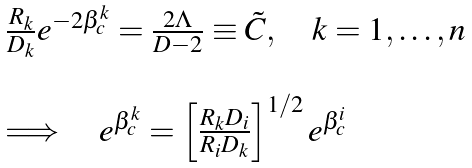Convert formula to latex. <formula><loc_0><loc_0><loc_500><loc_500>\begin{array} { l } \frac { R _ { k } } { D _ { k } } e ^ { - 2 \beta _ { c } ^ { k } } = \frac { 2 \Lambda } { D - 2 } \equiv \tilde { C } , \quad k = 1 , \dots , n \\ \\ \Longrightarrow \quad e ^ { \beta _ { c } ^ { k } } = \left [ \frac { R _ { k } D _ { i } } { R _ { i } D _ { k } } \right ] ^ { 1 / 2 } e ^ { \beta _ { c } ^ { i } } \end{array}</formula> 